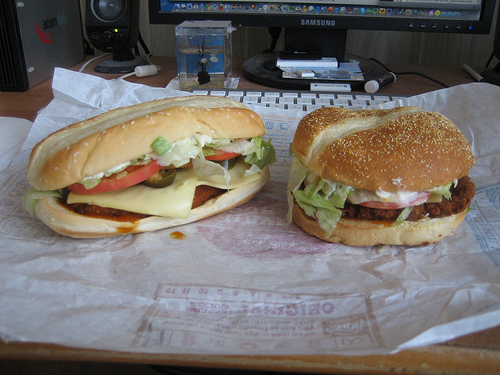Please provide the bounding box coordinate of the region this sentence describes: Piece of provolone sticking out of bun. Coordinates: [0.53, 0.22, 0.71, 0.28]. This points to a visible slice of provolone cheese extending out of the bun, adding a cheesy, delicious look to the hamburger. 